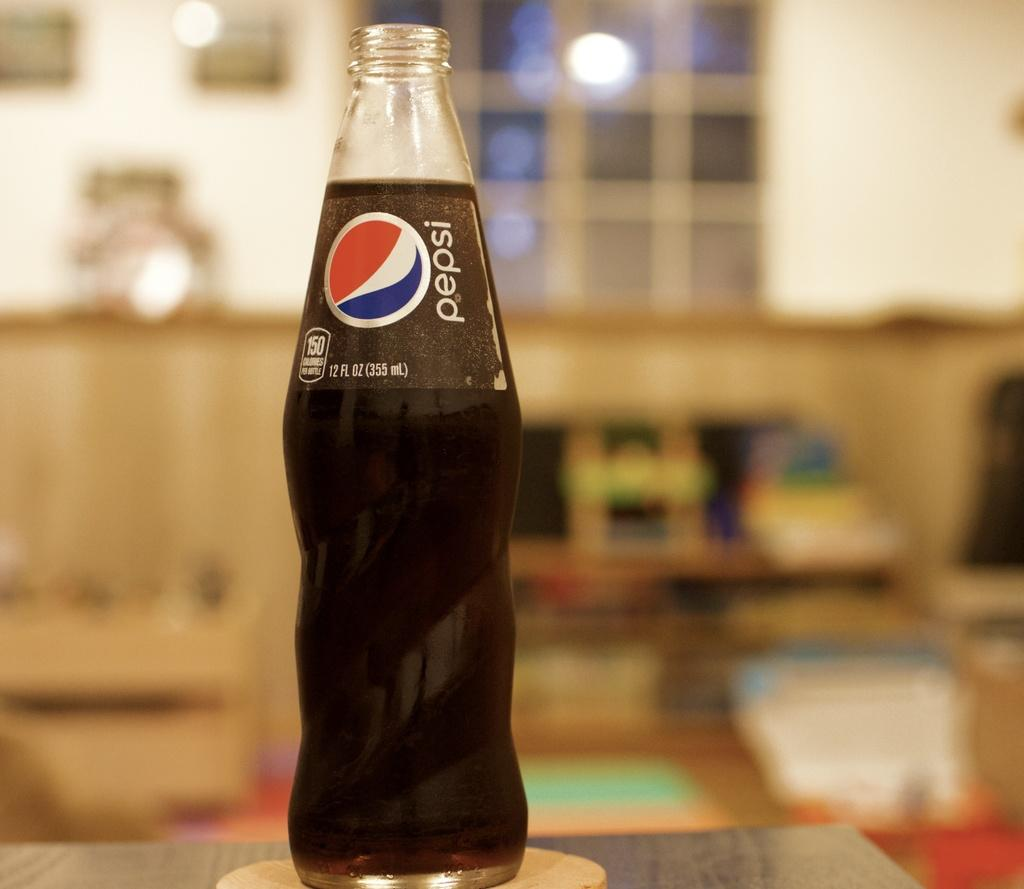What object is present in the image? There is a bottle in the image. What is inside the bottle? The bottle contains coke. Can you describe the background of the image? The background of the image is blurred. What type of brake can be seen on the bottle in the image? There is no brake present on the bottle in the image. Can you describe the veins visible in the coke inside the bottle? There are no veins visible in the coke inside the bottle; it is a liquid and does not have veins. 